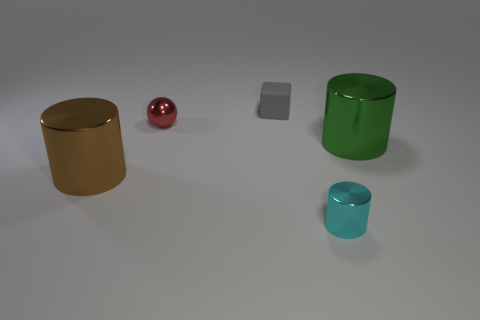There is a green thing that is made of the same material as the brown thing; what is its size?
Make the answer very short. Large. There is a cylinder behind the shiny cylinder left of the metallic cylinder that is in front of the big brown metallic cylinder; what size is it?
Make the answer very short. Large. There is a thing left of the small red metallic object; what is its size?
Offer a very short reply. Large. Does the metallic cylinder to the left of the small rubber object have the same size as the metallic object that is behind the green thing?
Give a very brief answer. No. What size is the cylinder that is behind the shiny cylinder on the left side of the gray rubber object?
Your response must be concise. Large. There is a object in front of the brown thing behind the tiny cylinder; what is it made of?
Your answer should be very brief. Metal. There is a big object that is to the left of the green thing; does it have the same shape as the tiny thing in front of the tiny ball?
Keep it short and to the point. Yes. There is a shiny thing that is both behind the big brown metal thing and to the right of the tiny matte object; what size is it?
Your answer should be very brief. Large. Is the material of the large cylinder that is on the right side of the gray block the same as the brown object?
Your answer should be compact. Yes. Is there any other thing that has the same size as the sphere?
Keep it short and to the point. Yes. 